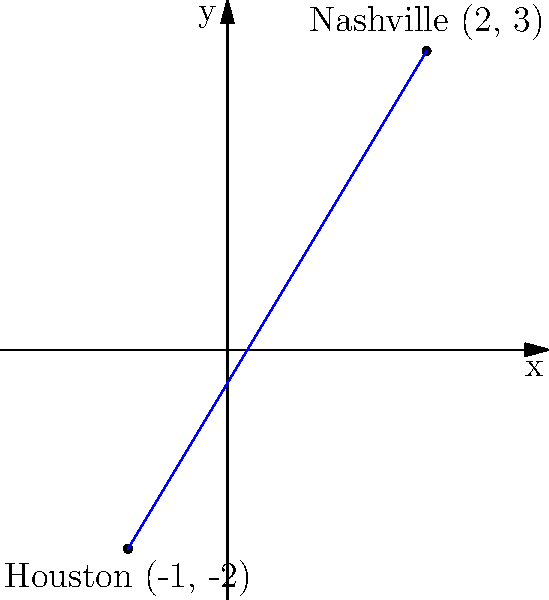Jim Reeves performed in Nashville and Houston during his career. On a coordinate plane, Nashville is located at (2, 3) and Houston at (-1, -2). Calculate the distance between these two cities using the distance formula. To solve this problem, we'll use the distance formula:

$$ d = \sqrt{(x_2 - x_1)^2 + (y_2 - y_1)^2} $$

Where $(x_1, y_1)$ is the coordinate of Nashville and $(x_2, y_2)$ is the coordinate of Houston.

Step 1: Identify the coordinates
Nashville: $(2, 3)$
Houston: $(-1, -2)$

Step 2: Plug the values into the distance formula
$$ d = \sqrt{(-1 - 2)^2 + (-2 - 3)^2} $$

Step 3: Simplify the expressions inside the parentheses
$$ d = \sqrt{(-3)^2 + (-5)^2} $$

Step 4: Calculate the squares
$$ d = \sqrt{9 + 25} $$

Step 5: Add the values under the square root
$$ d = \sqrt{34} $$

Step 6: Simplify the square root (if possible)
In this case, $\sqrt{34}$ cannot be simplified further.

Therefore, the distance between Nashville and Houston is $\sqrt{34}$ units.
Answer: $\sqrt{34}$ units 